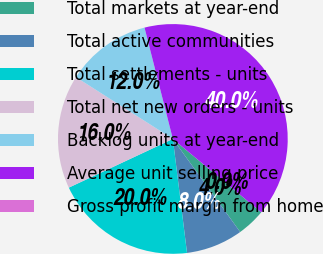<chart> <loc_0><loc_0><loc_500><loc_500><pie_chart><fcel>Total markets at year-end<fcel>Total active communities<fcel>Total settlements - units<fcel>Total net new orders - units<fcel>Backlog units at year-end<fcel>Average unit selling price<fcel>Gross profit margin from home<nl><fcel>4.0%<fcel>8.0%<fcel>20.0%<fcel>16.0%<fcel>12.0%<fcel>40.0%<fcel>0.0%<nl></chart> 